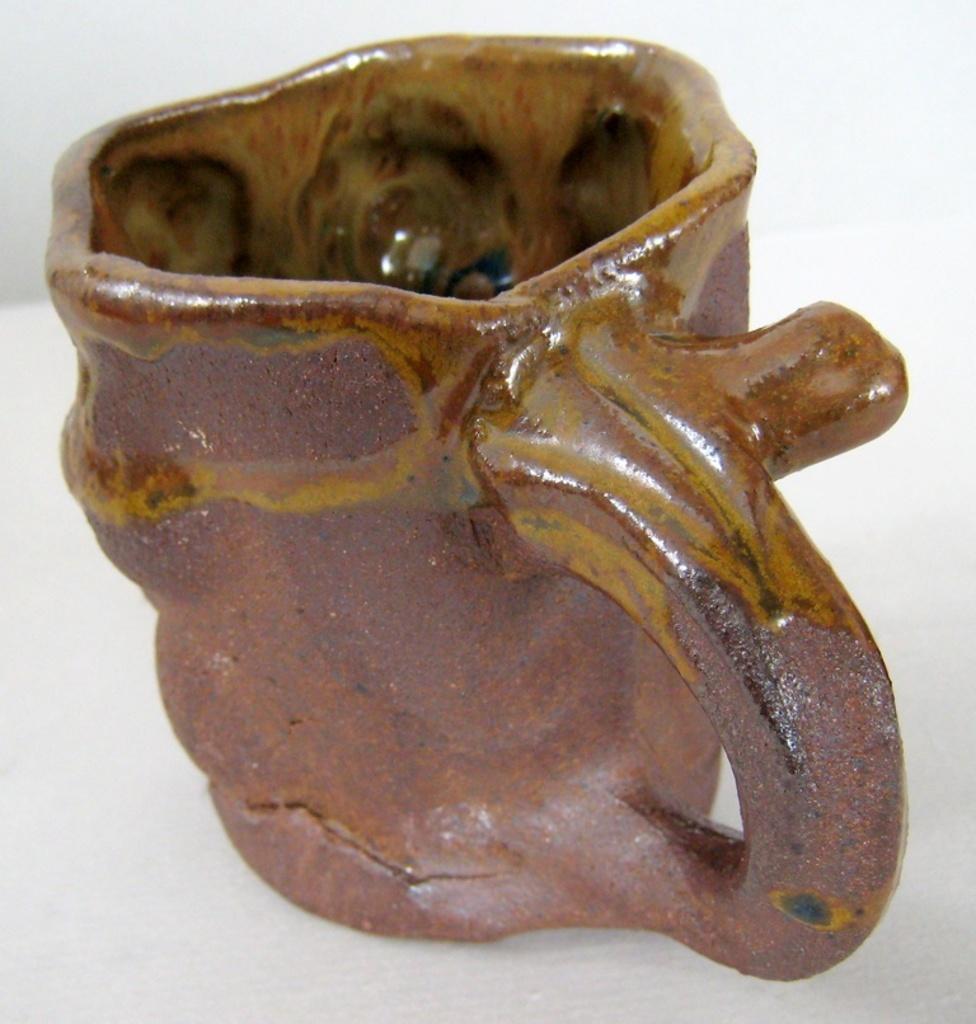Could you give a brief overview of what you see in this image? In this image we can see a cup in brown color. 